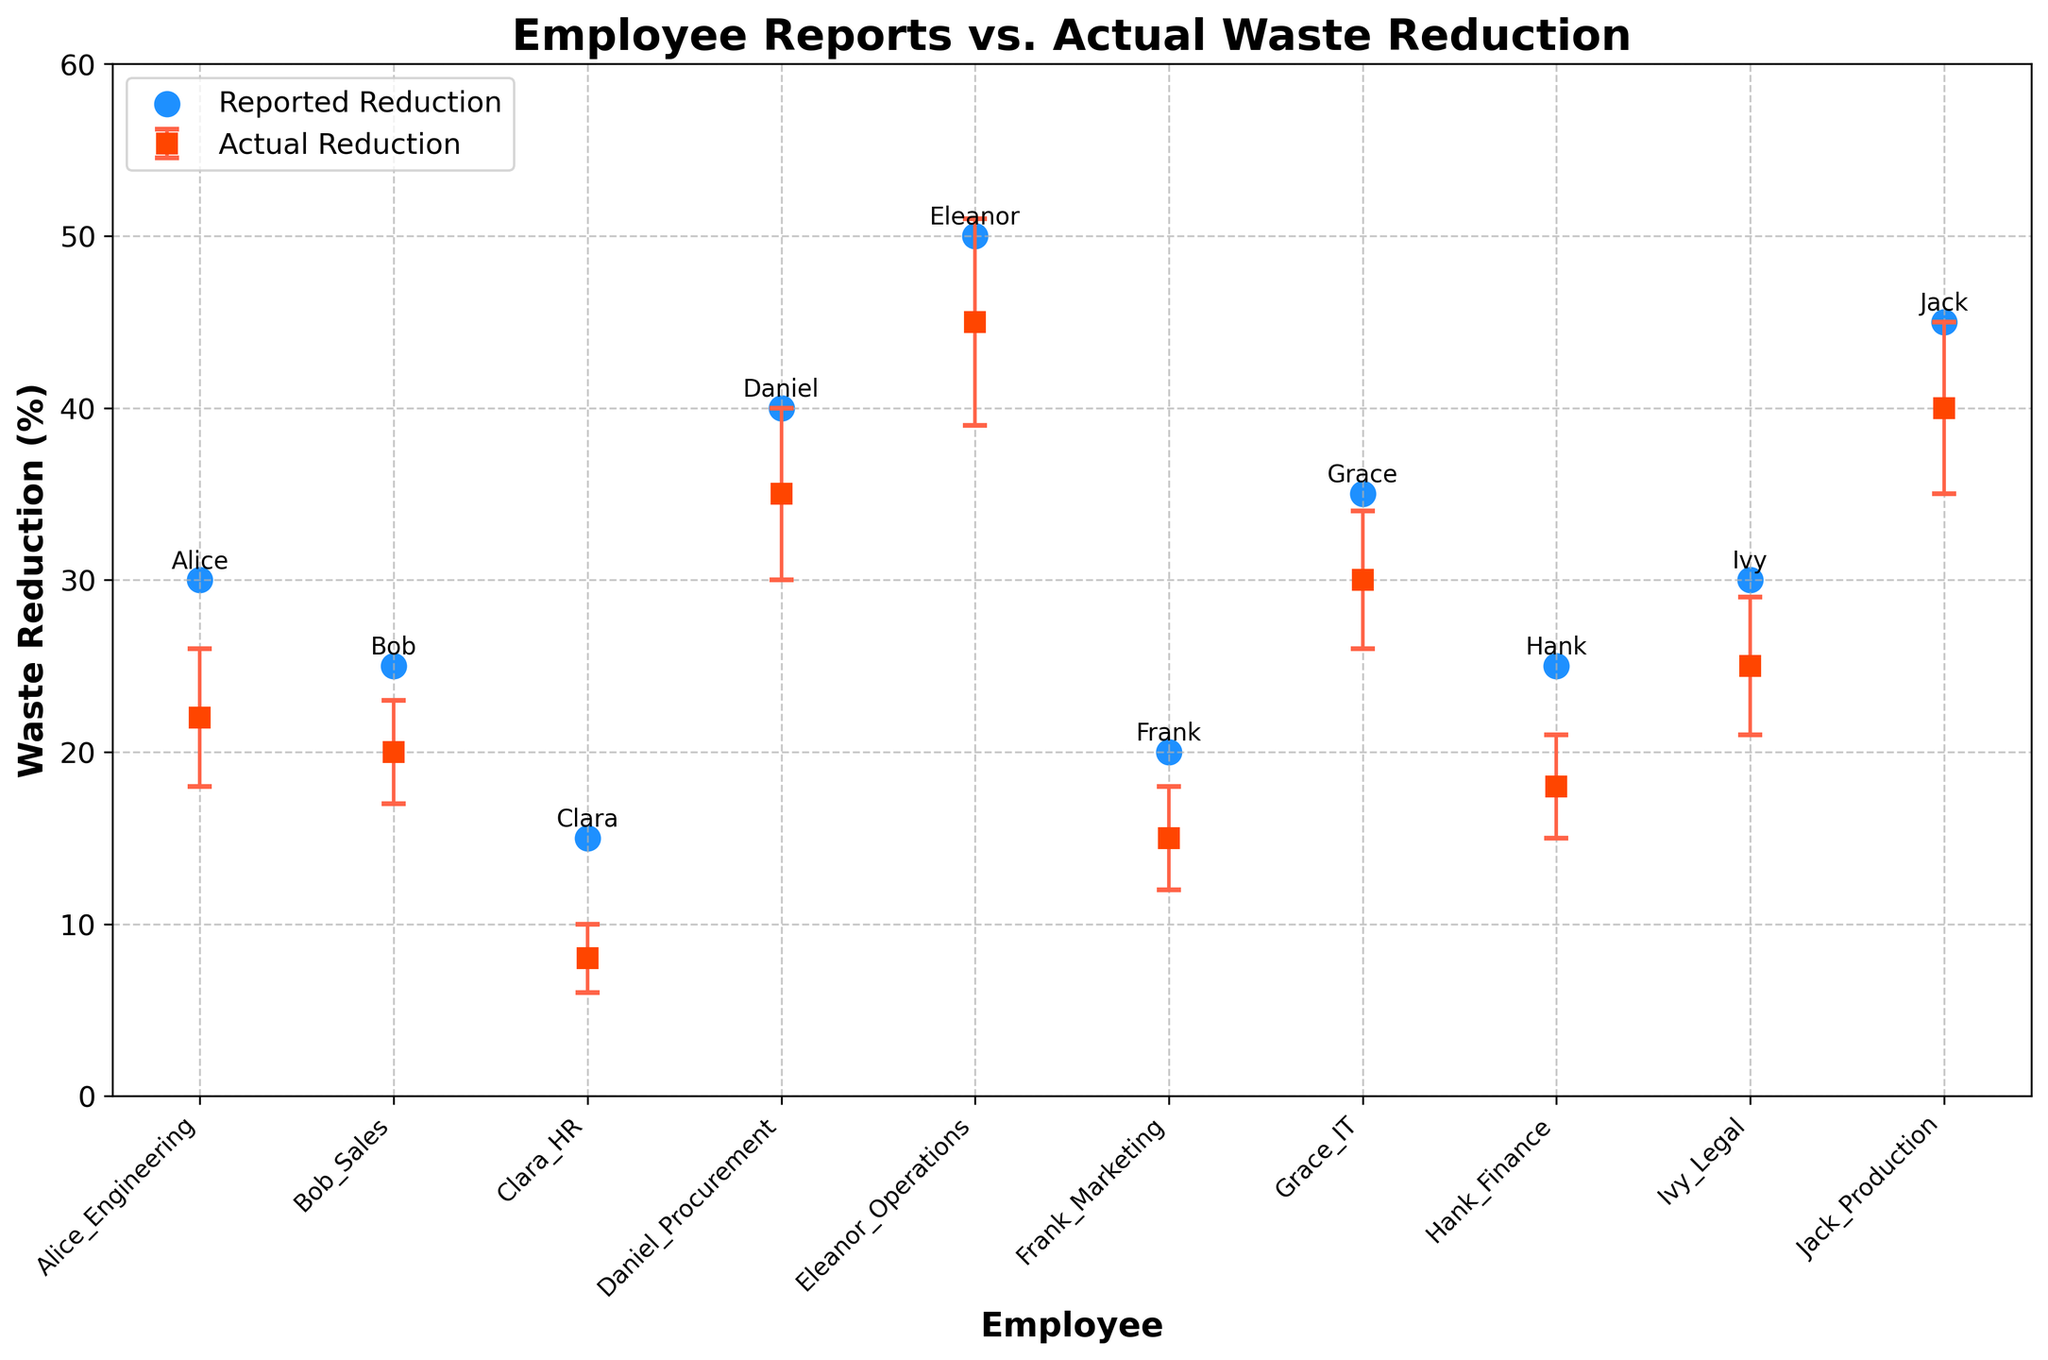How many employees are represented in the plot? Count the number of unique employee names on the x-axis.
Answer: 10 What's the highest reported waste reduction? Identify the highest value on the y-axis for the blue circles (reported reductions). The highest value is around 50%, which corresponds to Eleanor from Operations.
Answer: 50% Which employee reported the lowest waste reduction? Look for the blue circle with the lowest y-axis value. Clara from HR reported the lowest waste reduction, which is around 15%.
Answer: Clara, HR What's the average reported waste reduction across all employees? Sum all the reported reductions and divide by the number of employees. (30 + 25 + 15 + 40 + 50 + 20 + 35 + 25 + 30 + 45) / 10 = 31.5%
Answer: 31.5% Which employee has the largest discrepancy between reported and actual waste reduction? Compare the differences between reported (blue circles) and actual (red squares) waste reductions for each employee. Calculate the absolute differences and identify the largest one. In this case, Clara from HR shows the largest discrepancy (15% reported vs. 8% actual -> a difference of 7%).
Answer: Clara, HR Which employee’s actual waste reduction falls above the error bound? Check the actual (red squares) values along with upper error bounds (top of the error bars). Eleanor from Operations, with actual waste reduction 45% (at top of error bar 51%), falls above the error bound.
Answer: Eleanor, Operations What’s the average actual waste reduction across all employees? Sum all actual reductions and divide by the number of employees. (22 + 20 + 8 + 35 + 45 + 15 + 30 + 18 + 25 + 40) / 10 = 25.8%
Answer: 25.8% Which two employees have similar reported reductions but differ significantly in actual waste reductions? Look for blue circles close together on the y-axis but corresponding red squares relatively far apart. For example, Alice from Engineering (30% reported) and Ivy from Legal (30% reported) have similar reported reductions, but their actual waste reductions are 22% and 25% respectively (a 3% difference isn’t significant, so check others). In this case, Grace from IT (35% reported) and Hank from Finance (25% reported) differ significantly in actual waste reductions (30% and 18%, respectively, a 12% difference).
Answer: Grace, IT and Hank, Finance What's the discrepancy between reported and actual waste reductions for Eleanor from Operations? Subtract Eleanor’s actual waste reduction from her reported reduction. 50% (reported) - 45% (actual) = 5%
Answer: 5% 